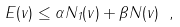<formula> <loc_0><loc_0><loc_500><loc_500>E ( v ) \leq \alpha N _ { 1 } ( v ) + \beta N ( v ) \ ,</formula> 